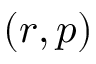Convert formula to latex. <formula><loc_0><loc_0><loc_500><loc_500>( r , p )</formula> 